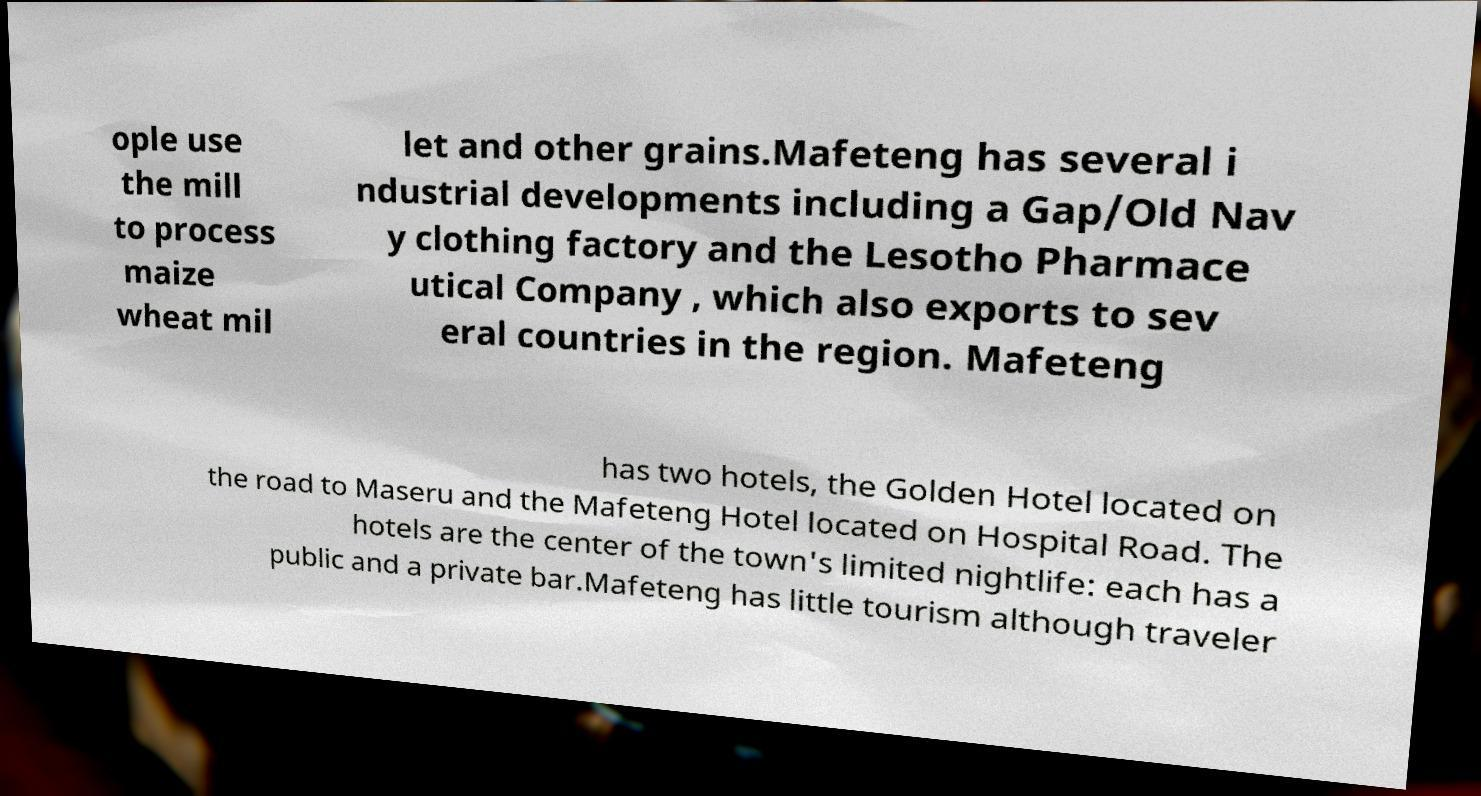Can you read and provide the text displayed in the image?This photo seems to have some interesting text. Can you extract and type it out for me? ople use the mill to process maize wheat mil let and other grains.Mafeteng has several i ndustrial developments including a Gap/Old Nav y clothing factory and the Lesotho Pharmace utical Company , which also exports to sev eral countries in the region. Mafeteng has two hotels, the Golden Hotel located on the road to Maseru and the Mafeteng Hotel located on Hospital Road. The hotels are the center of the town's limited nightlife: each has a public and a private bar.Mafeteng has little tourism although traveler 